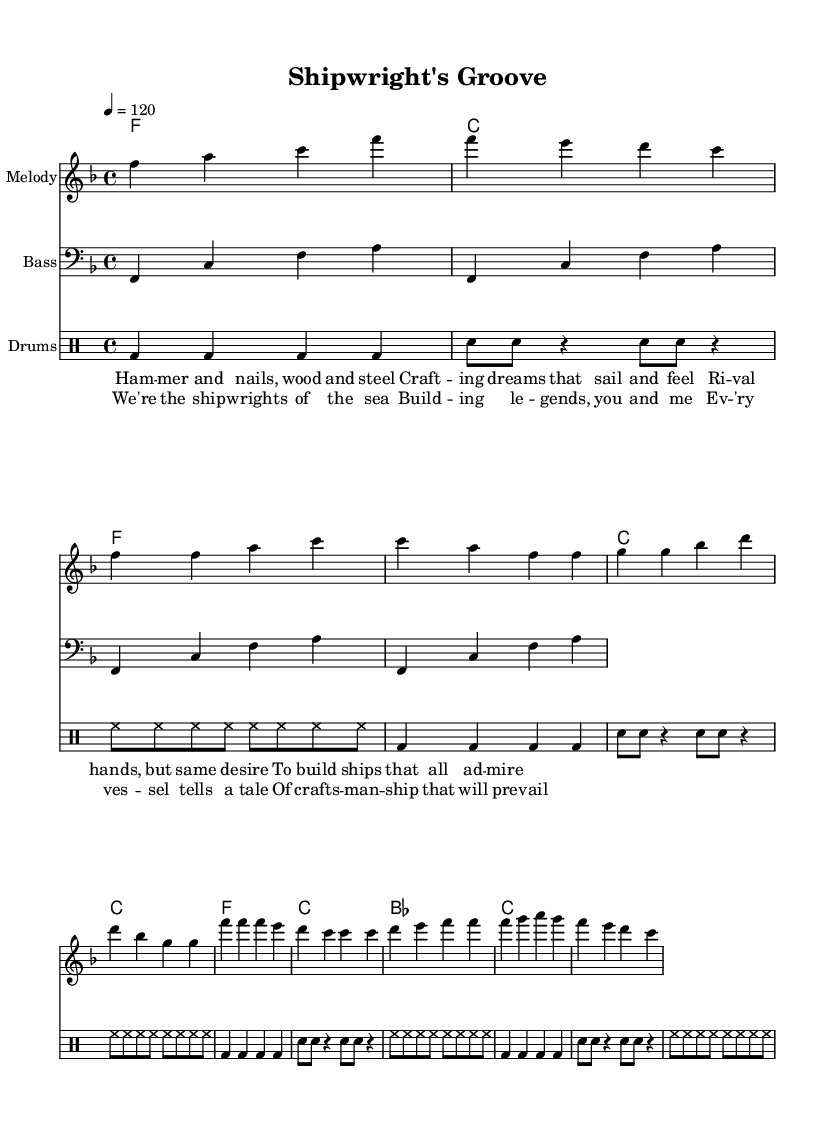What is the key signature of this music? The key signature is F major, as indicated at the beginning of the score, which has one flat (B flat).
Answer: F major What is the time signature of this music? The time signature is 4/4, which is noted at the beginning of the score and signifies that there are four beats per measure.
Answer: 4/4 What is the tempo marking for this piece? The tempo marking indicates a speed of 120 beats per minute, noted with "4 = 120" at the beginning of the piece.
Answer: 120 What is the first note of the melody? The first note in the melody is F, which is the starting note in the introduction section.
Answer: F How many measures are in the chorus section? The chorus contains eight measures, as can be counted by looking at the sections and grouping the notes together.
Answer: 8 How does the bass line interact with the melody? The bass line supports the melody by playing a repetitive pattern that complements the harmonic progression and adds depth to the overall sound.
Answer: Supports melody What theme is celebrated in the lyrics of this piece? The lyrics celebrate shipbuilding and the artistry involved, as reflected in phrases about crafting dreams and building legends.
Answer: Shipbuilding 